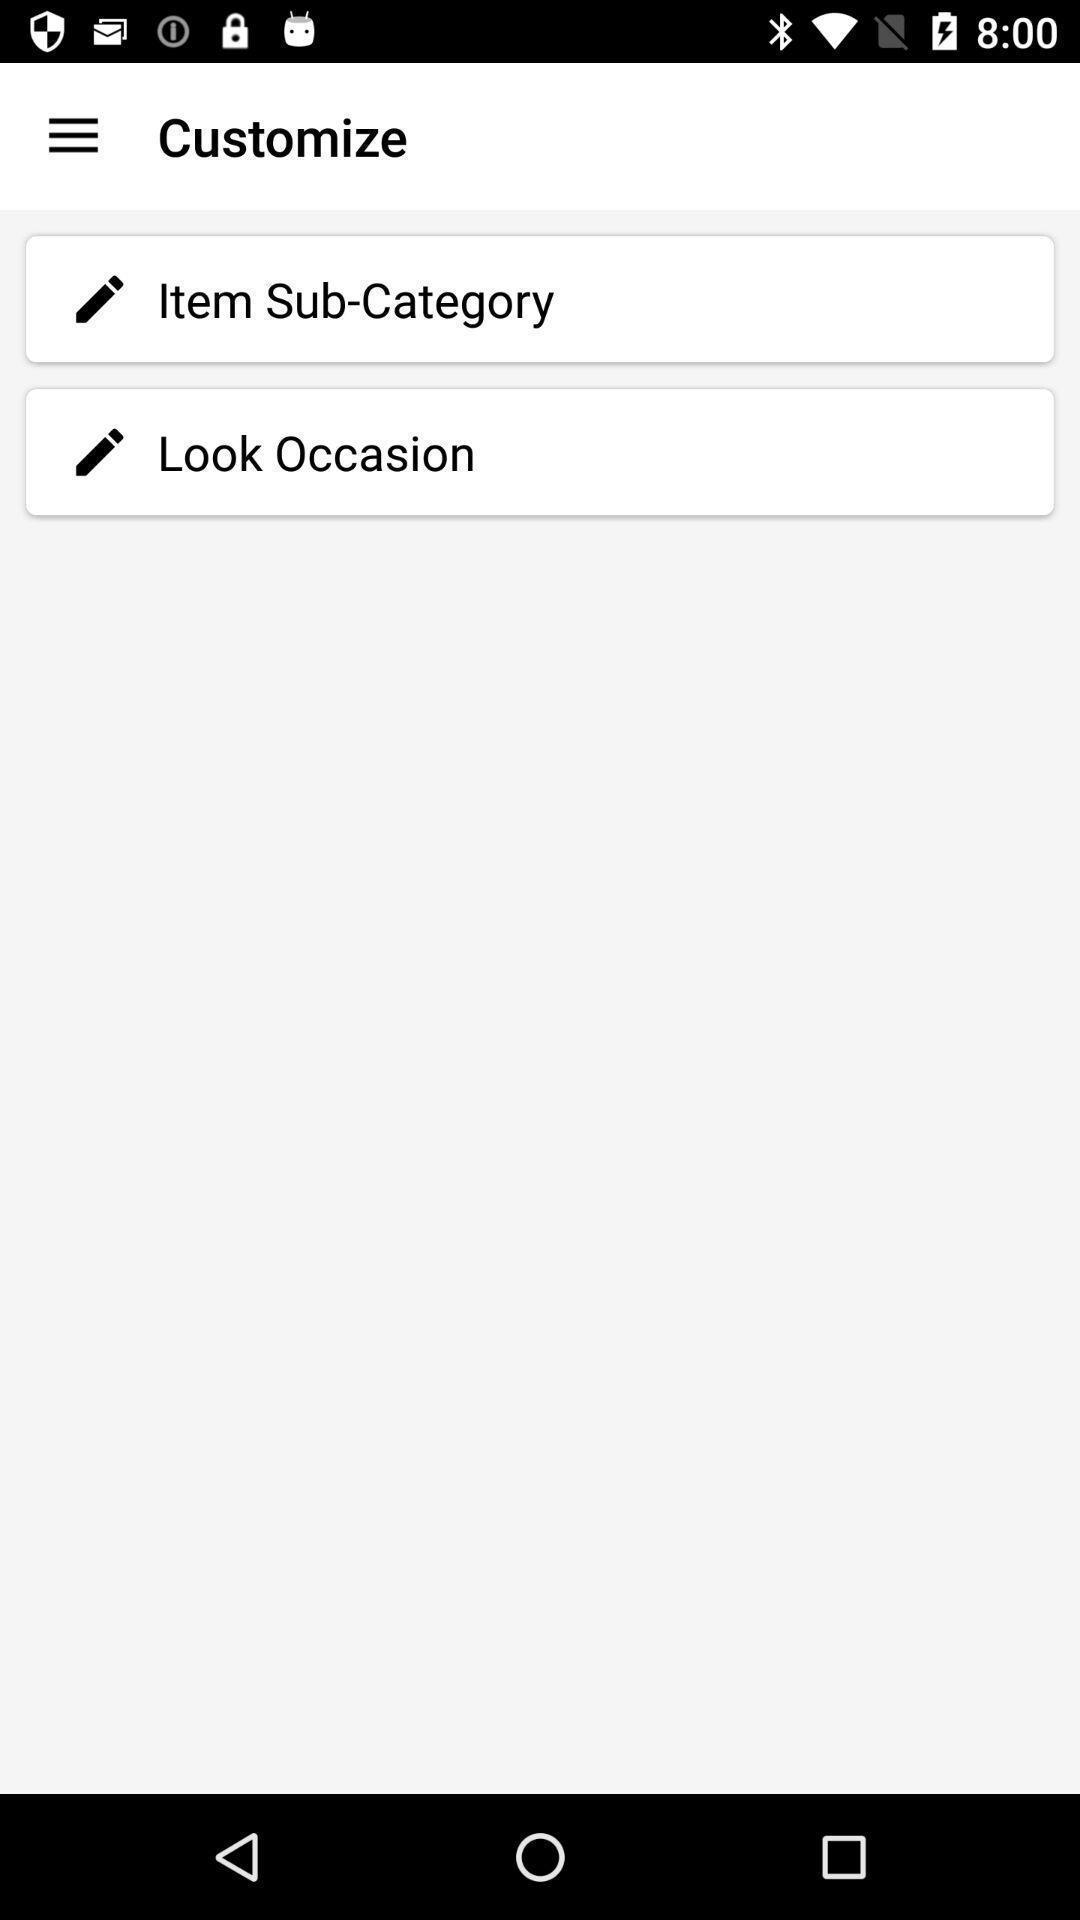What details can you identify in this image? Screen shows to customize an item. 